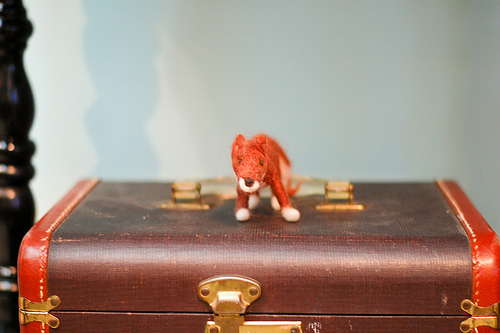<image>
Can you confirm if the toy is in front of the trunk? No. The toy is not in front of the trunk. The spatial positioning shows a different relationship between these objects. 